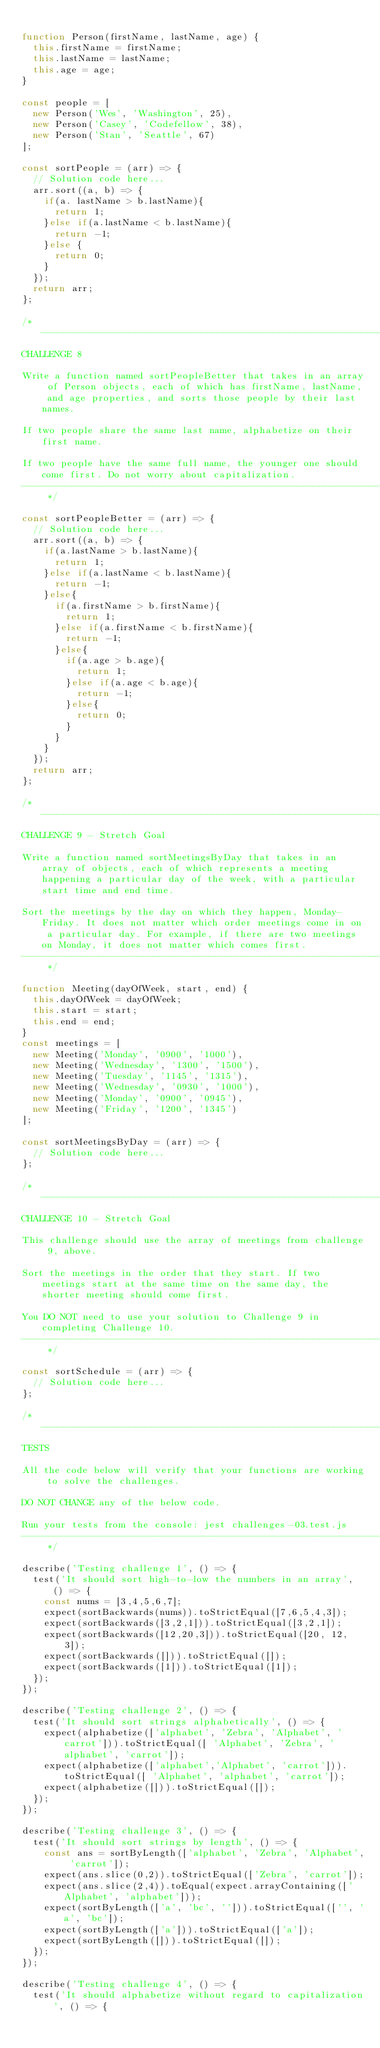Convert code to text. <code><loc_0><loc_0><loc_500><loc_500><_JavaScript_>
function Person(firstName, lastName, age) {
  this.firstName = firstName;
  this.lastName = lastName;
  this.age = age;
}

const people = [
  new Person('Wes', 'Washington', 25),
  new Person('Casey', 'Codefellow', 38),
  new Person('Stan', 'Seattle', 67)
];

const sortPeople = (arr) => {
  // Solution code here...
  arr.sort((a, b) => {
    if(a. lastName > b.lastName){
      return 1;
    }else if(a.lastName < b.lastName){
      return -1;
    }else {
      return 0;
    }
  });
  return arr;
};

/* ------------------------------------------------------------------------------------------------
CHALLENGE 8

Write a function named sortPeopleBetter that takes in an array of Person objects, each of which has firstName, lastName, and age properties, and sorts those people by their last names.

If two people share the same last name, alphabetize on their first name.

If two people have the same full name, the younger one should come first. Do not worry about capitalization.
------------------------------------------------------------------------------------------------ */

const sortPeopleBetter = (arr) => {
  // Solution code here...
  arr.sort((a, b) => {
    if(a.lastName > b.lastName){
      return 1;
    }else if(a.lastName < b.lastName){
      return -1;   
    }else{
      if(a.firstName > b.firstName){
        return 1;
      }else if(a.firstName < b.firstName){
        return -1;   
      }else{
        if(a.age > b.age){
          return 1;
        }else if(a.age < b.age){
          return -1;   
        }else{
          return 0;
        }
      }
    }
  });
  return arr;
};

/* ------------------------------------------------------------------------------------------------
CHALLENGE 9 - Stretch Goal

Write a function named sortMeetingsByDay that takes in an array of objects, each of which represents a meeting happening a particular day of the week, with a particular start time and end time.

Sort the meetings by the day on which they happen, Monday-Friday. It does not matter which order meetings come in on a particular day. For example, if there are two meetings on Monday, it does not matter which comes first.
------------------------------------------------------------------------------------------------ */

function Meeting(dayOfWeek, start, end) {
  this.dayOfWeek = dayOfWeek;
  this.start = start;
  this.end = end;
}
const meetings = [
  new Meeting('Monday', '0900', '1000'),
  new Meeting('Wednesday', '1300', '1500'),
  new Meeting('Tuesday', '1145', '1315'),
  new Meeting('Wednesday', '0930', '1000'),
  new Meeting('Monday', '0900', '0945'),
  new Meeting('Friday', '1200', '1345')
];

const sortMeetingsByDay = (arr) => {
  // Solution code here...
};

/* ------------------------------------------------------------------------------------------------
CHALLENGE 10 - Stretch Goal

This challenge should use the array of meetings from challenge 9, above.

Sort the meetings in the order that they start. If two meetings start at the same time on the same day, the shorter meeting should come first.

You DO NOT need to use your solution to Challenge 9 in completing Challenge 10.
------------------------------------------------------------------------------------------------ */

const sortSchedule = (arr) => {
  // Solution code here...
};

/* ------------------------------------------------------------------------------------------------
TESTS

All the code below will verify that your functions are working to solve the challenges.

DO NOT CHANGE any of the below code.

Run your tests from the console: jest challenges-03.test.js
------------------------------------------------------------------------------------------------ */

describe('Testing challenge 1', () => {
  test('It should sort high-to-low the numbers in an array', () => {
    const nums = [3,4,5,6,7];
    expect(sortBackwards(nums)).toStrictEqual([7,6,5,4,3]);
    expect(sortBackwards([3,2,1])).toStrictEqual([3,2,1]);
    expect(sortBackwards([12,20,3])).toStrictEqual([20, 12, 3]);
    expect(sortBackwards([])).toStrictEqual([]);
    expect(sortBackwards([1])).toStrictEqual([1]);
  });
});

describe('Testing challenge 2', () => {
  test('It should sort strings alphabetically', () => {
    expect(alphabetize(['alphabet', 'Zebra', 'Alphabet', 'carrot'])).toStrictEqual([ 'Alphabet', 'Zebra', 'alphabet', 'carrot']);
    expect(alphabetize(['alphabet','Alphabet', 'carrot'])).toStrictEqual([ 'Alphabet', 'alphabet', 'carrot']);
    expect(alphabetize([])).toStrictEqual([]);
  });
});

describe('Testing challenge 3', () => {
  test('It should sort strings by length', () => {
    const ans = sortByLength(['alphabet', 'Zebra', 'Alphabet', 'carrot']);
    expect(ans.slice(0,2)).toStrictEqual(['Zebra', 'carrot']);
    expect(ans.slice(2,4)).toEqual(expect.arrayContaining(['Alphabet', 'alphabet']));
    expect(sortByLength(['a', 'bc', ''])).toStrictEqual(['', 'a', 'bc']);
    expect(sortByLength(['a'])).toStrictEqual(['a']);
    expect(sortByLength([])).toStrictEqual([]);
  });
});

describe('Testing challenge 4', () => {
  test('It should alphabetize without regard to capitalization', () => {</code> 